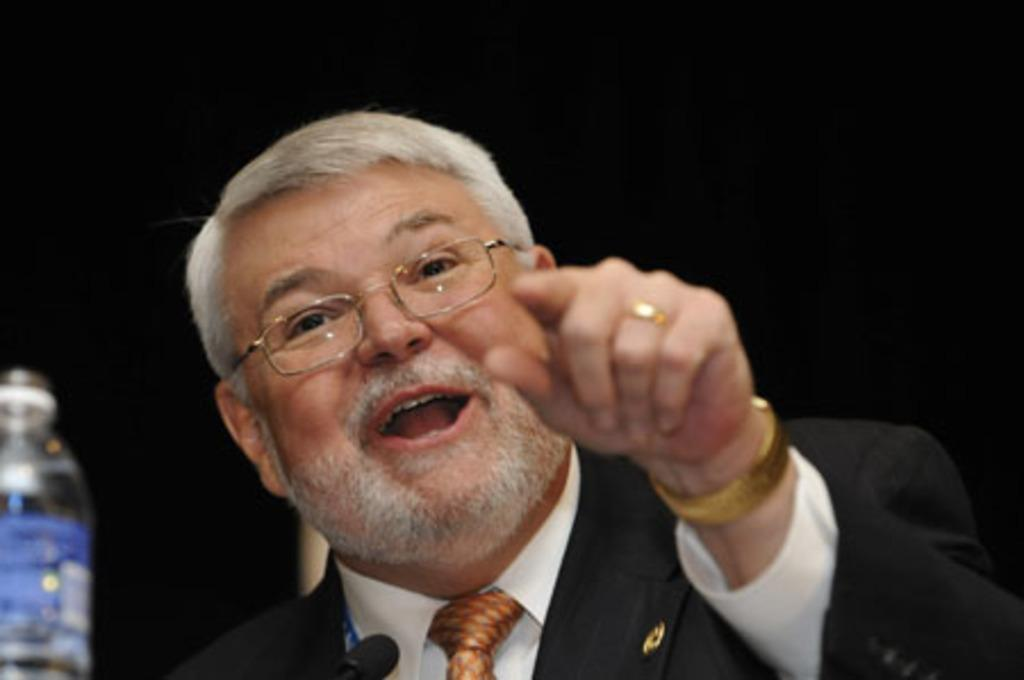What is the main subject of the image? There is a person in the image. What is the person wearing in the image? The person is wearing a coat, a tie, and glasses in the image. What objects can be seen in the image besides the person? There is a mic and a bottle in the image. How would you describe the background of the image? The background of the image is dark. What channel does the person regret watching in the image? There is no indication of any channels or regret in the image; it only shows a person wearing a coat, tie, and glasses, with a mic and a bottle nearby. 